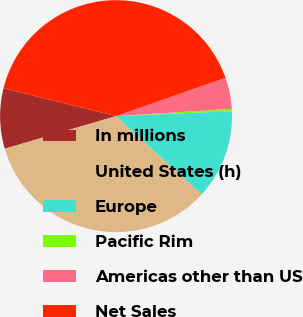Convert chart. <chart><loc_0><loc_0><loc_500><loc_500><pie_chart><fcel>In millions<fcel>United States (h)<fcel>Europe<fcel>Pacific Rim<fcel>Americas other than US<fcel>Net Sales<nl><fcel>8.41%<fcel>33.69%<fcel>12.45%<fcel>0.32%<fcel>4.36%<fcel>40.77%<nl></chart> 